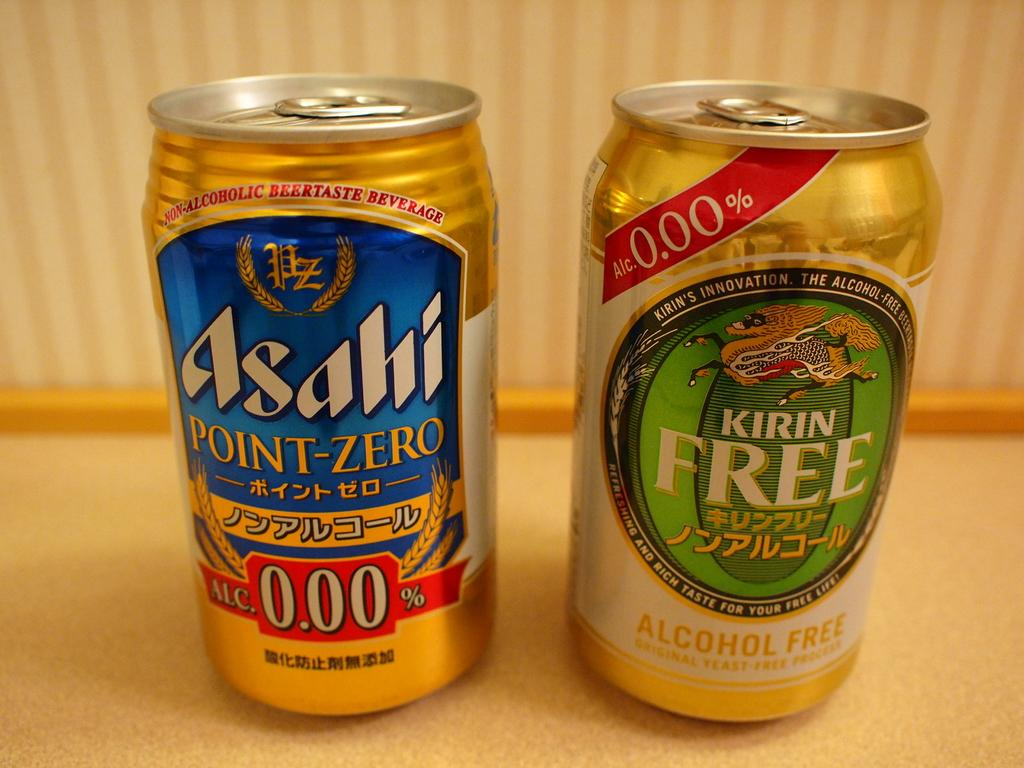<image>
Describe the image concisely. a couple of cans with one that says 0.00 on it 